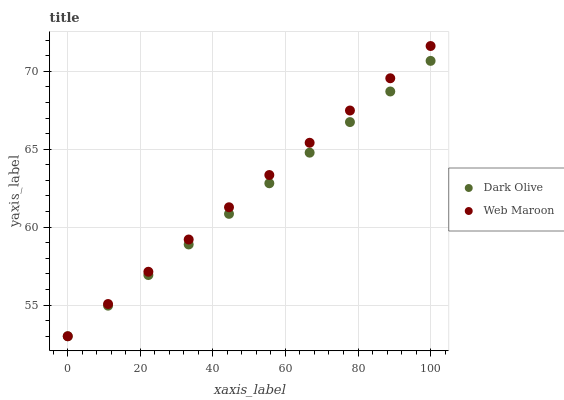Does Dark Olive have the minimum area under the curve?
Answer yes or no. Yes. Does Web Maroon have the maximum area under the curve?
Answer yes or no. Yes. Does Web Maroon have the minimum area under the curve?
Answer yes or no. No. Is Web Maroon the smoothest?
Answer yes or no. Yes. Is Dark Olive the roughest?
Answer yes or no. Yes. Is Web Maroon the roughest?
Answer yes or no. No. Does Dark Olive have the lowest value?
Answer yes or no. Yes. Does Web Maroon have the highest value?
Answer yes or no. Yes. Does Web Maroon intersect Dark Olive?
Answer yes or no. Yes. Is Web Maroon less than Dark Olive?
Answer yes or no. No. Is Web Maroon greater than Dark Olive?
Answer yes or no. No. 